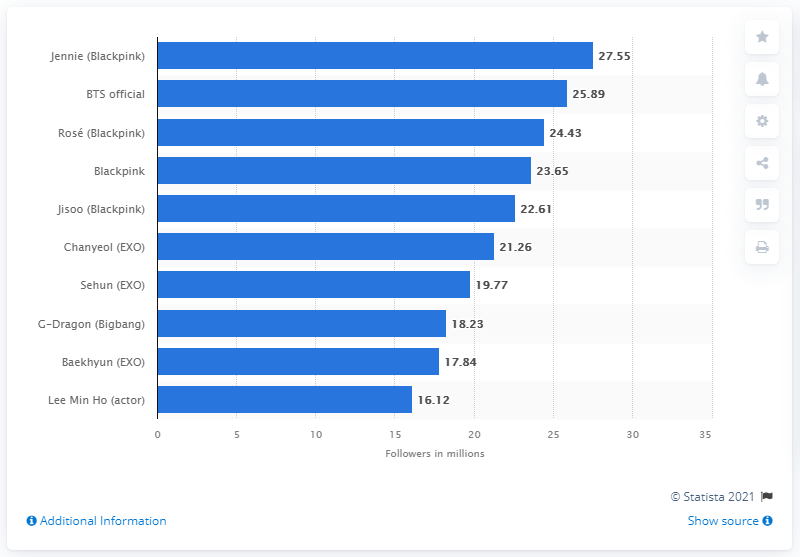Give some essential details in this illustration. As of June 2020, Jennie had 27.55 followers on Instagram. 